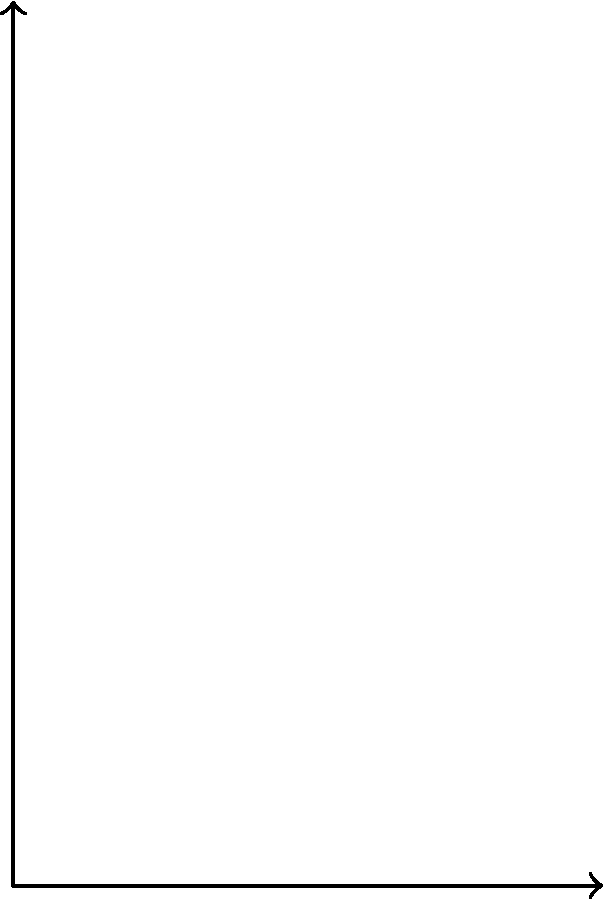Two sprinters, A and B, are preparing for a race. Sprinter A has a mass of 70 kg and exerts a force of 980 N on the starting blocks. Sprinter B, with a mass of 75 kg, exerts a force of 1050 N. Assuming both sprinters push off with the same acceleration, which sprinter will have the advantage at the start? Justify your answer using Newton's Second Law. To determine which sprinter has the advantage at the start, we need to compare their accelerations using Newton's Second Law: $F = ma$.

Step 1: Calculate the acceleration for Sprinter A
$a_A = \frac{F_A}{m_A} = \frac{980 \text{ N}}{70 \text{ kg}} = 14 \text{ m/s}^2$

Step 2: Calculate the acceleration for Sprinter B
$a_B = \frac{F_B}{m_B} = \frac{1050 \text{ N}}{75 \text{ kg}} = 14 \text{ m/s}^2$

Step 3: Compare the accelerations
Both sprinters have the same acceleration of 14 m/s².

Step 4: Interpret the results
Since both sprinters have the same acceleration, neither has an advantage at the start based solely on their force output and mass. The increased force exerted by Sprinter B is proportional to their increased mass, resulting in the same acceleration as Sprinter A.

This demonstrates that in sprinting, the ratio of force to mass is more important than absolute force or mass alone. Other factors, such as technique and reaction time, would likely play a more significant role in determining who has the advantage at the start.
Answer: Neither sprinter has an advantage; both have equal acceleration of 14 m/s². 